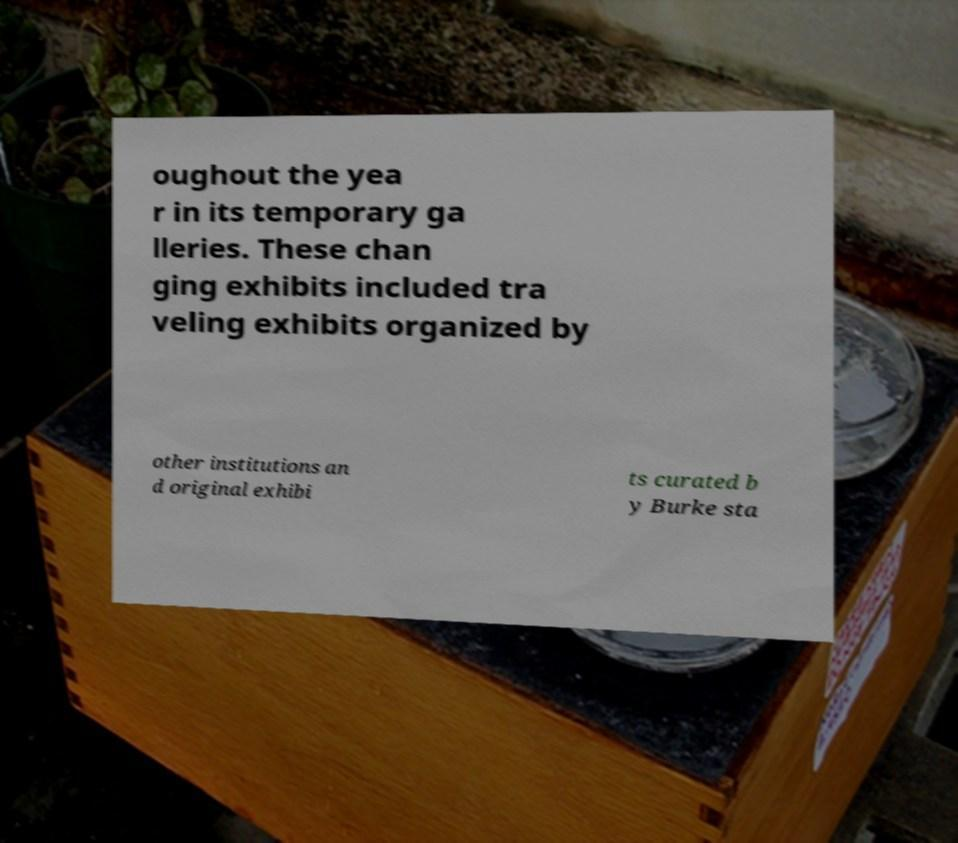For documentation purposes, I need the text within this image transcribed. Could you provide that? oughout the yea r in its temporary ga lleries. These chan ging exhibits included tra veling exhibits organized by other institutions an d original exhibi ts curated b y Burke sta 